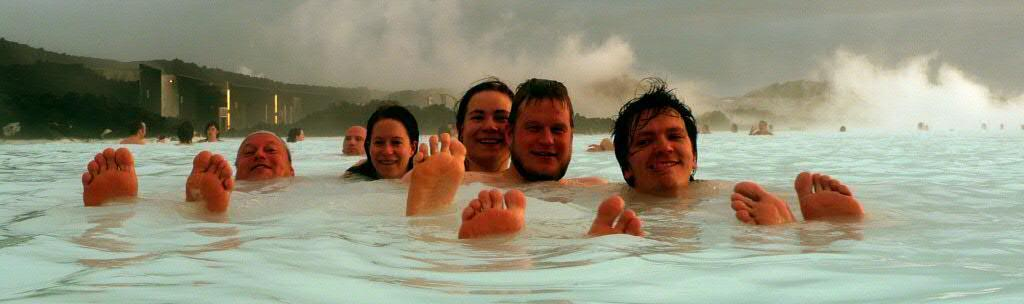What are the people in the image doing? There are groups of people in the water, suggesting they are swimming or engaging in water activities. What can be seen behind the people in the water? There is a building visible behind the people. What type of landscape is visible in the background of the image? There are hills in the background of the image. What atmospheric condition is present in the background of the image? Fog is present in the background of the image. What part of the natural environment is visible in the image? The sky is visible in the background of the image. What type of stem can be seen growing from the water in the image? There is no stem visible in the water in the image. What type of station is present in the image? There is no station present in the image. 